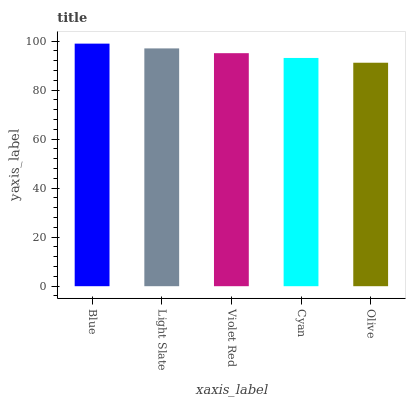Is Olive the minimum?
Answer yes or no. Yes. Is Blue the maximum?
Answer yes or no. Yes. Is Light Slate the minimum?
Answer yes or no. No. Is Light Slate the maximum?
Answer yes or no. No. Is Blue greater than Light Slate?
Answer yes or no. Yes. Is Light Slate less than Blue?
Answer yes or no. Yes. Is Light Slate greater than Blue?
Answer yes or no. No. Is Blue less than Light Slate?
Answer yes or no. No. Is Violet Red the high median?
Answer yes or no. Yes. Is Violet Red the low median?
Answer yes or no. Yes. Is Cyan the high median?
Answer yes or no. No. Is Olive the low median?
Answer yes or no. No. 